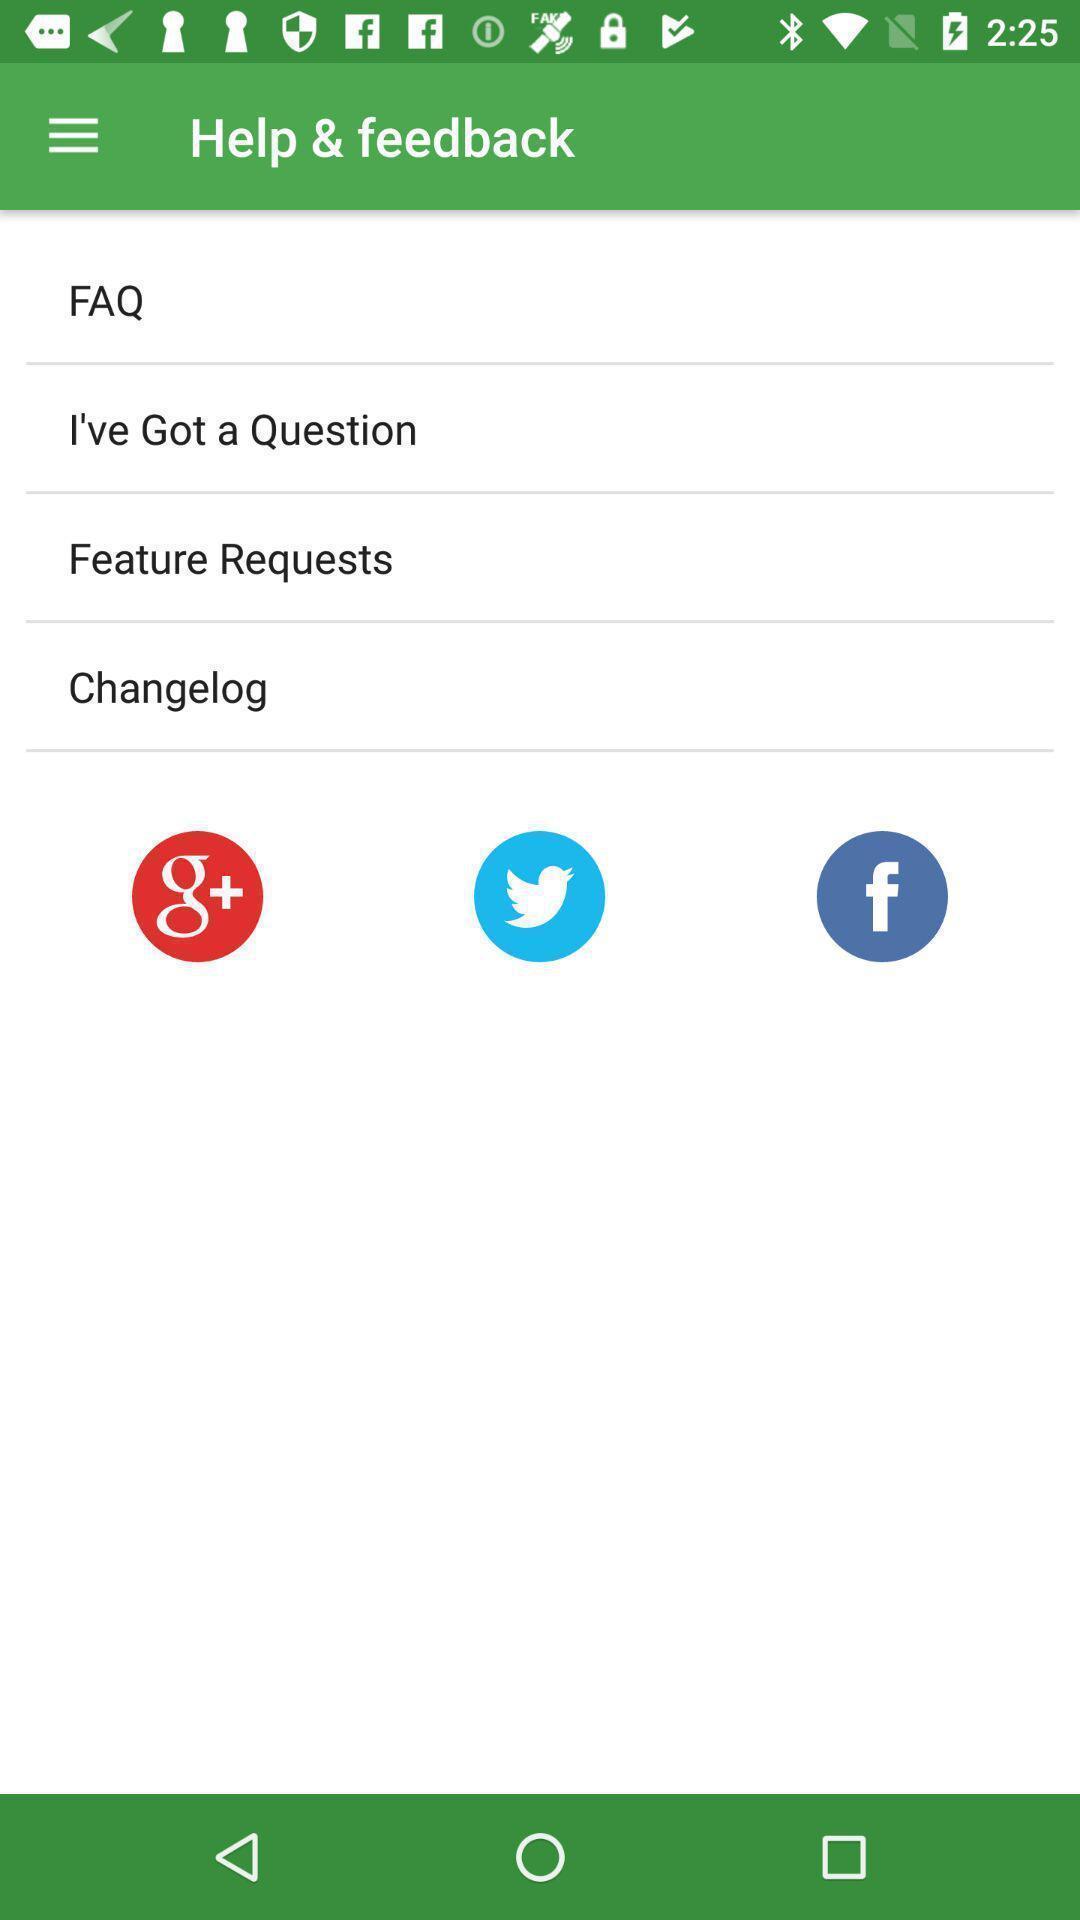What can you discern from this picture? Page showing multiple options for help and feedback. 